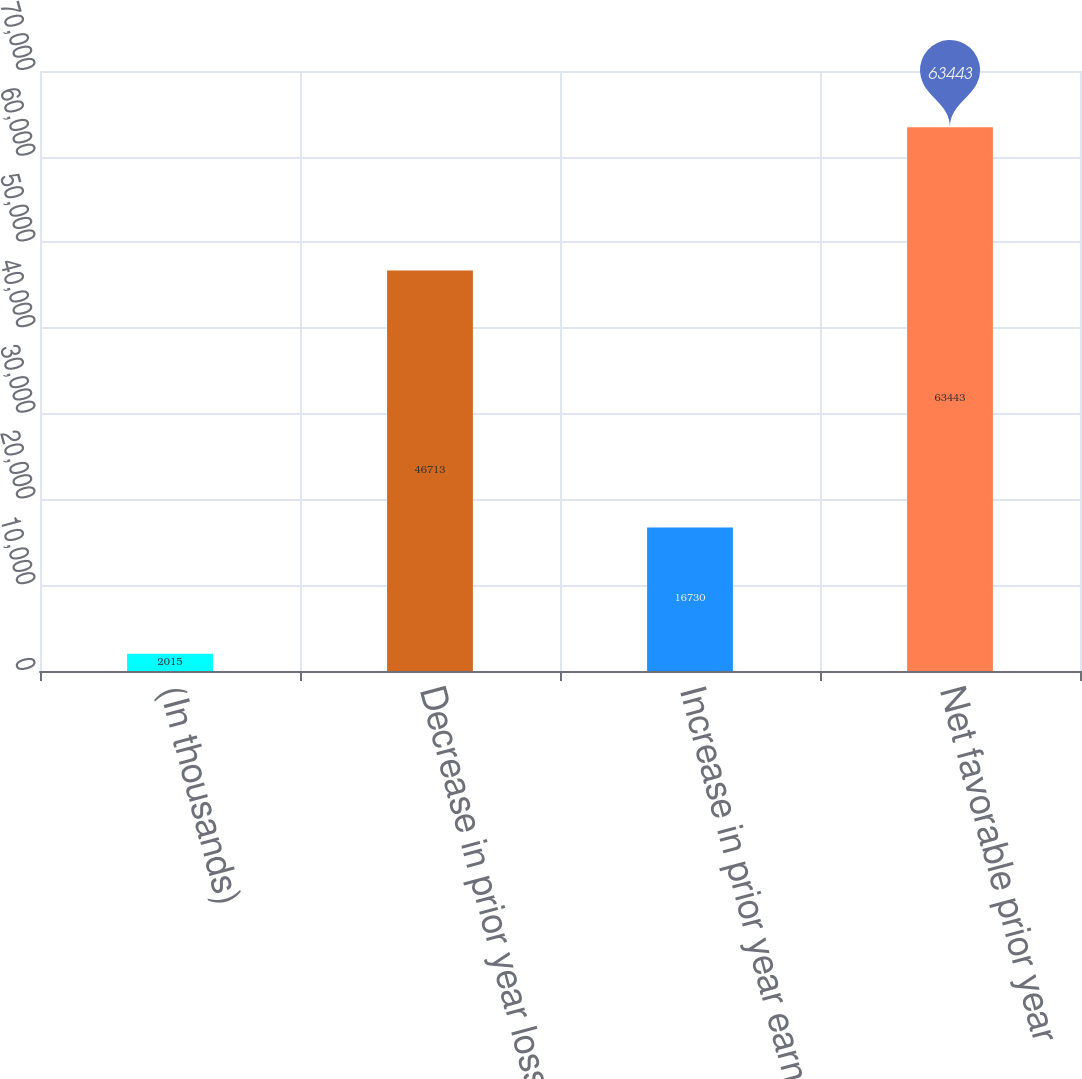<chart> <loc_0><loc_0><loc_500><loc_500><bar_chart><fcel>(In thousands)<fcel>Decrease in prior year loss<fcel>Increase in prior year earned<fcel>Net favorable prior year<nl><fcel>2015<fcel>46713<fcel>16730<fcel>63443<nl></chart> 